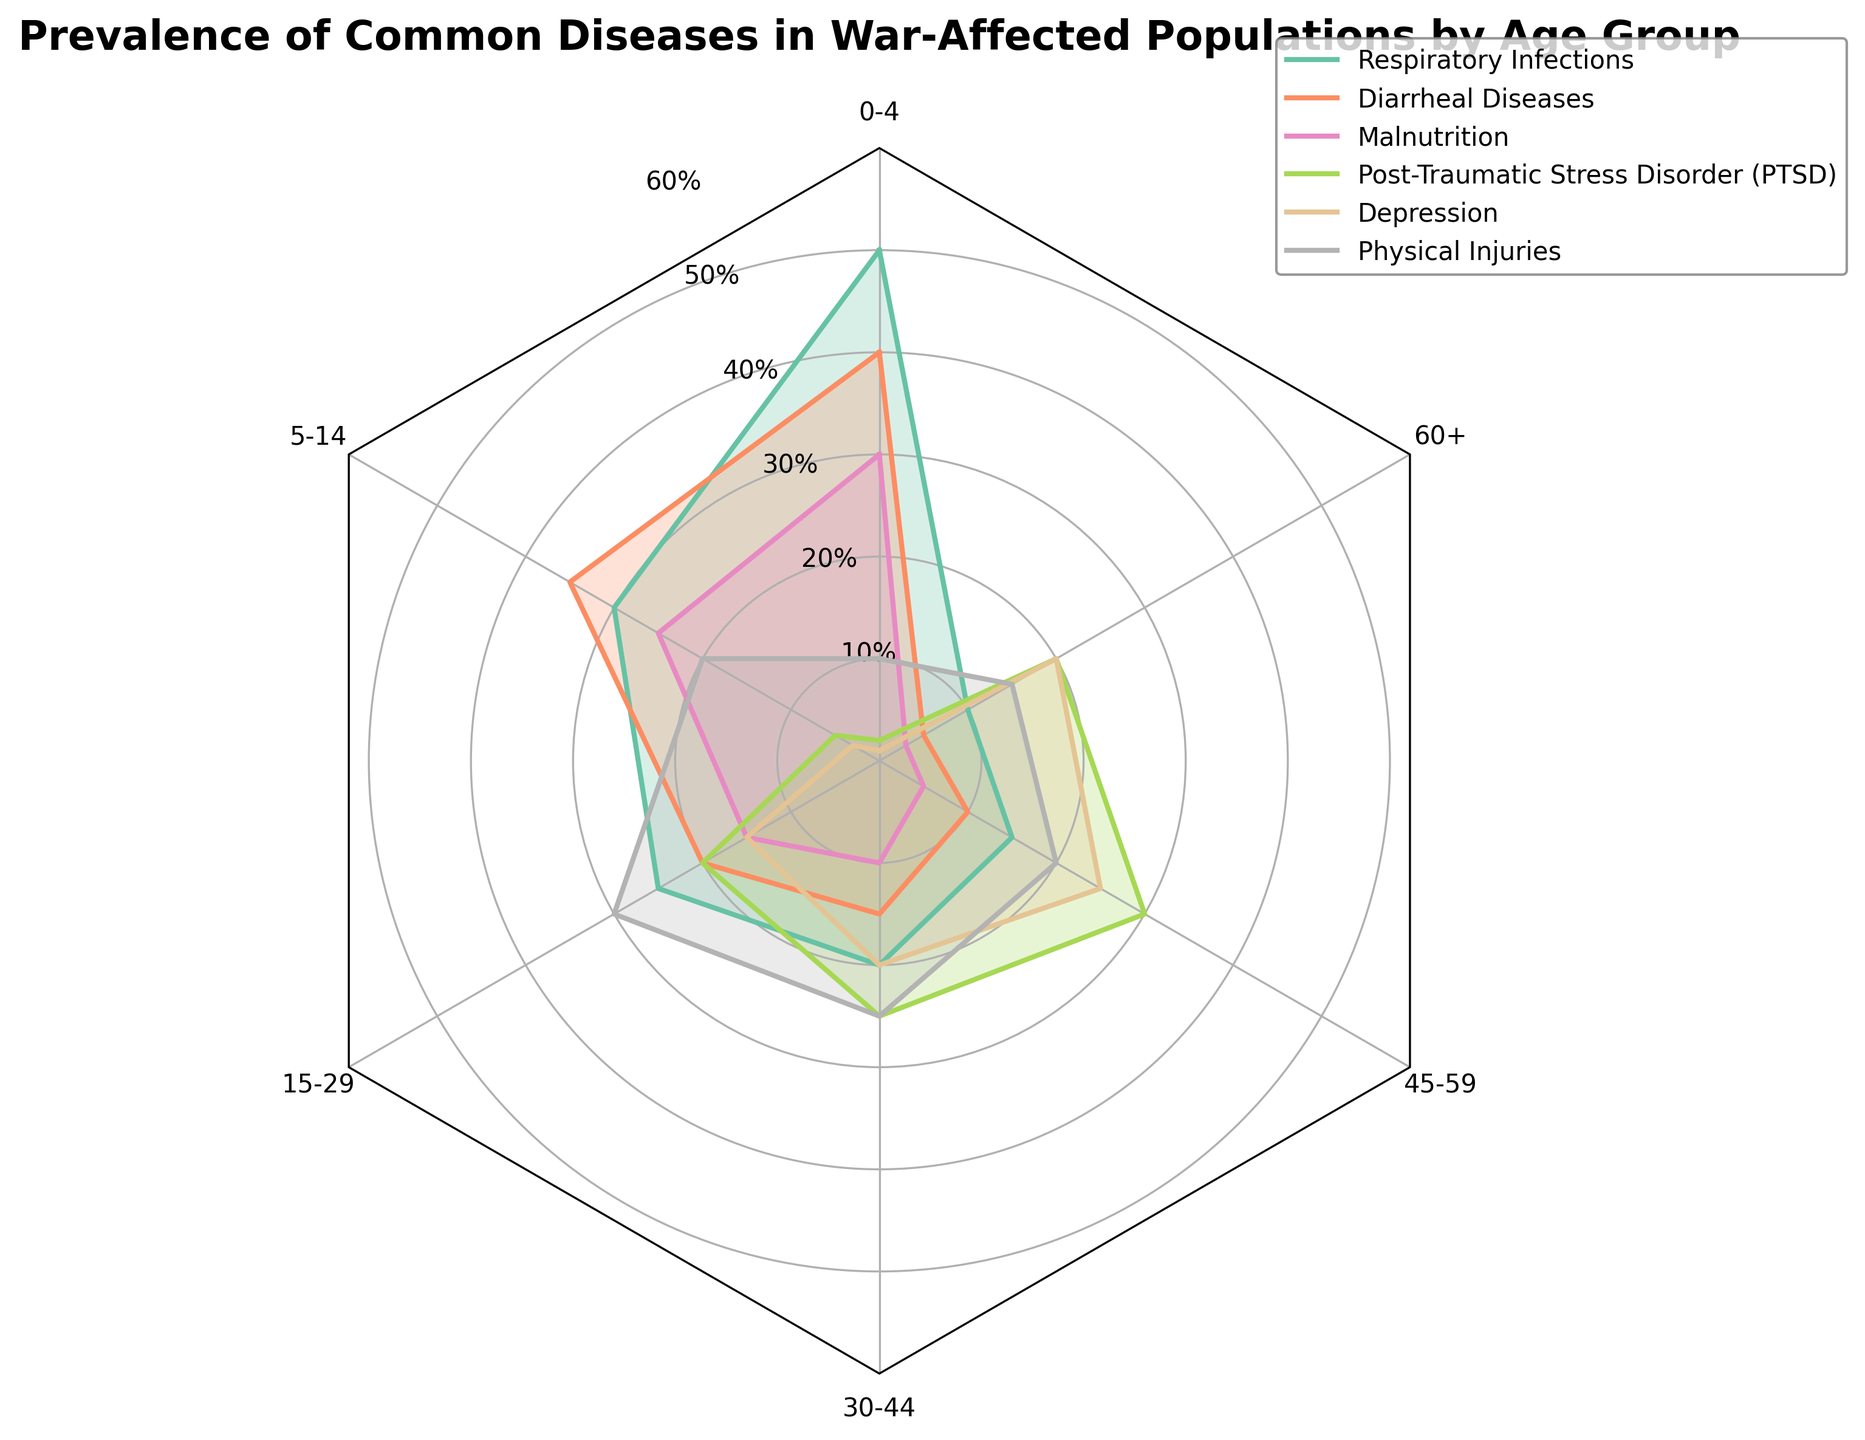Which disease has the highest prevalence across the 0-4 age group? Look at the values on the radar chart for the 0-4 age group. The highest value on this segment corresponds to Respiratory Infections which has a value of 50%.
Answer: Respiratory Infections Which disease shows the lowest prevalence in the 60+ age group? Check the 60+ segment of the radar chart and identify the lowest percentage. Malnutrition has the lowest prevalence at 3%.
Answer: Malnutrition Compare the prevalence of PTSD between the 0-4 and 45-59 age groups. Look at the radar chart for the values related to PTSD. For the 0-4 age group, it is 2%, and for the 45-59 age group, it is 30%. Hence, PTSD is significantly higher in the 45-59 age group.
Answer: Higher in 45-59 What's the average prevalence of Depression in the age groups 15-29 and 30-44? Find the values for Depression in these age groups. They are 15% and 20%. The average is (15 + 20) / 2 = 17.5%.
Answer: 17.5% Which age group shows the highest prevalence of Physical Injuries? Inspect the radar chart to find the highest value for Physical Injuries across all age groups. The 15-29 age group reveals the peak value at 30%.
Answer: 15-29 How does the prevalence of Respiratory Infections change from the youngest to the oldest age group? Observe the values of Respiratory Infections starting from the 0-4 age group to the 60+ age group. The values are 50%, 30%, 25%, 20%, 15%, and 10%, showing a consistent decline with increasing age.
Answer: Decreases Identify the disease with the most variability in prevalence across age groups. Look for the disease with the widest range between its highest and lowest values on the radar chart. PTSD ranges from 2% to 30%, showing the most variability.
Answer: PTSD Compare the prevalence of Diarrheal Diseases and Malnutrition in the 5-14 age group. Which one is higher? On the radar chart, these age groups have values of 35% for Diarrheal Diseases and 25% for Malnutrition. Therefore, Diarrheal Diseases are higher.
Answer: Diarrheal Diseases Which disease exhibits a consistently decreasing trend with age group? Examine each disease’s values across all age groups. Diarrheal Diseases, Malnutrition, and Respiratory Infections exhibit consistently decreasing trends. Choose one of them for the answer.
Answer: Respiratory Infections 